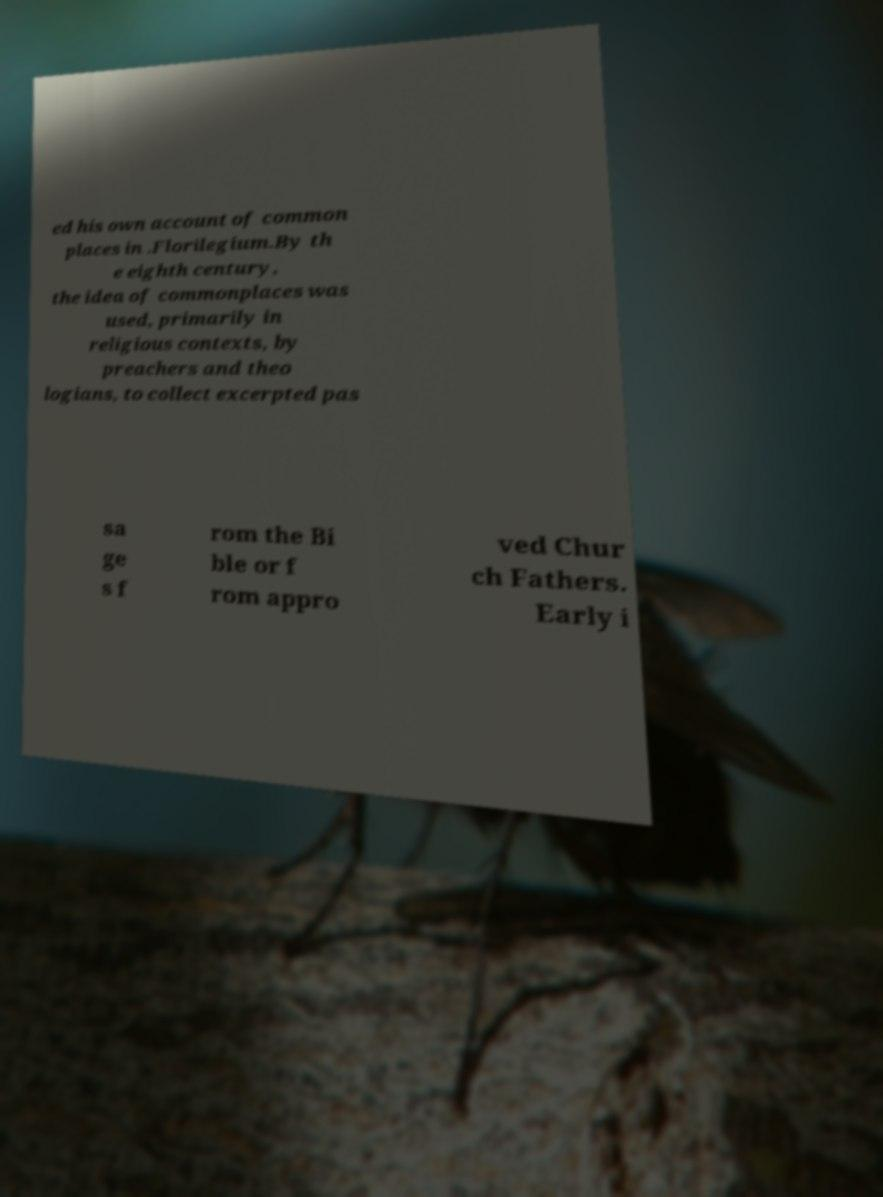What messages or text are displayed in this image? I need them in a readable, typed format. ed his own account of common places in .Florilegium.By th e eighth century, the idea of commonplaces was used, primarily in religious contexts, by preachers and theo logians, to collect excerpted pas sa ge s f rom the Bi ble or f rom appro ved Chur ch Fathers. Early i 